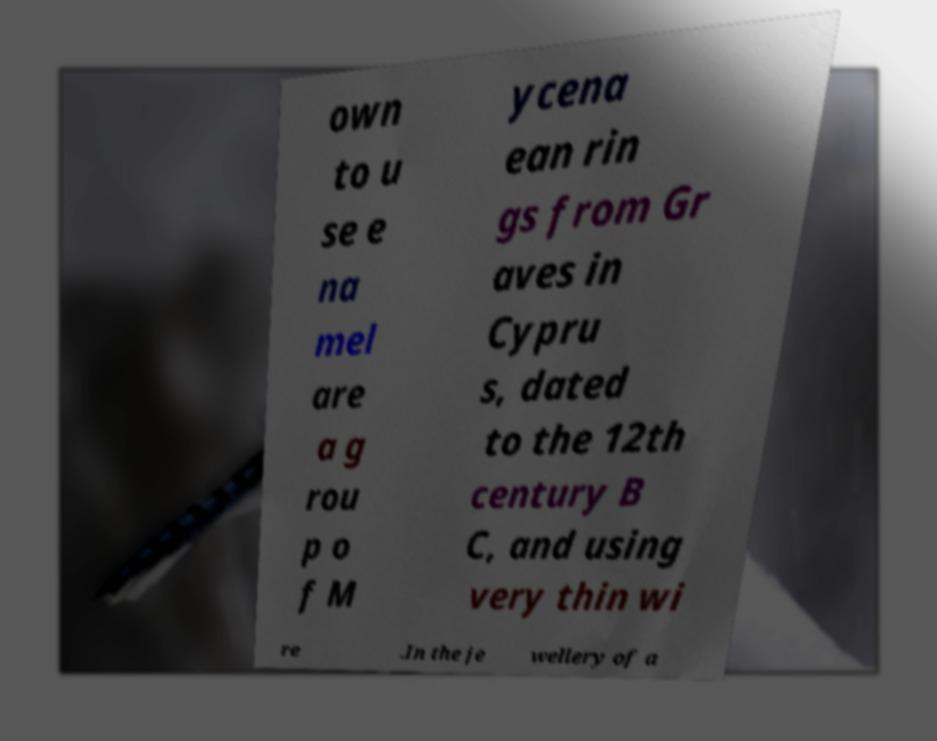Can you read and provide the text displayed in the image?This photo seems to have some interesting text. Can you extract and type it out for me? own to u se e na mel are a g rou p o f M ycena ean rin gs from Gr aves in Cypru s, dated to the 12th century B C, and using very thin wi re .In the je wellery of a 